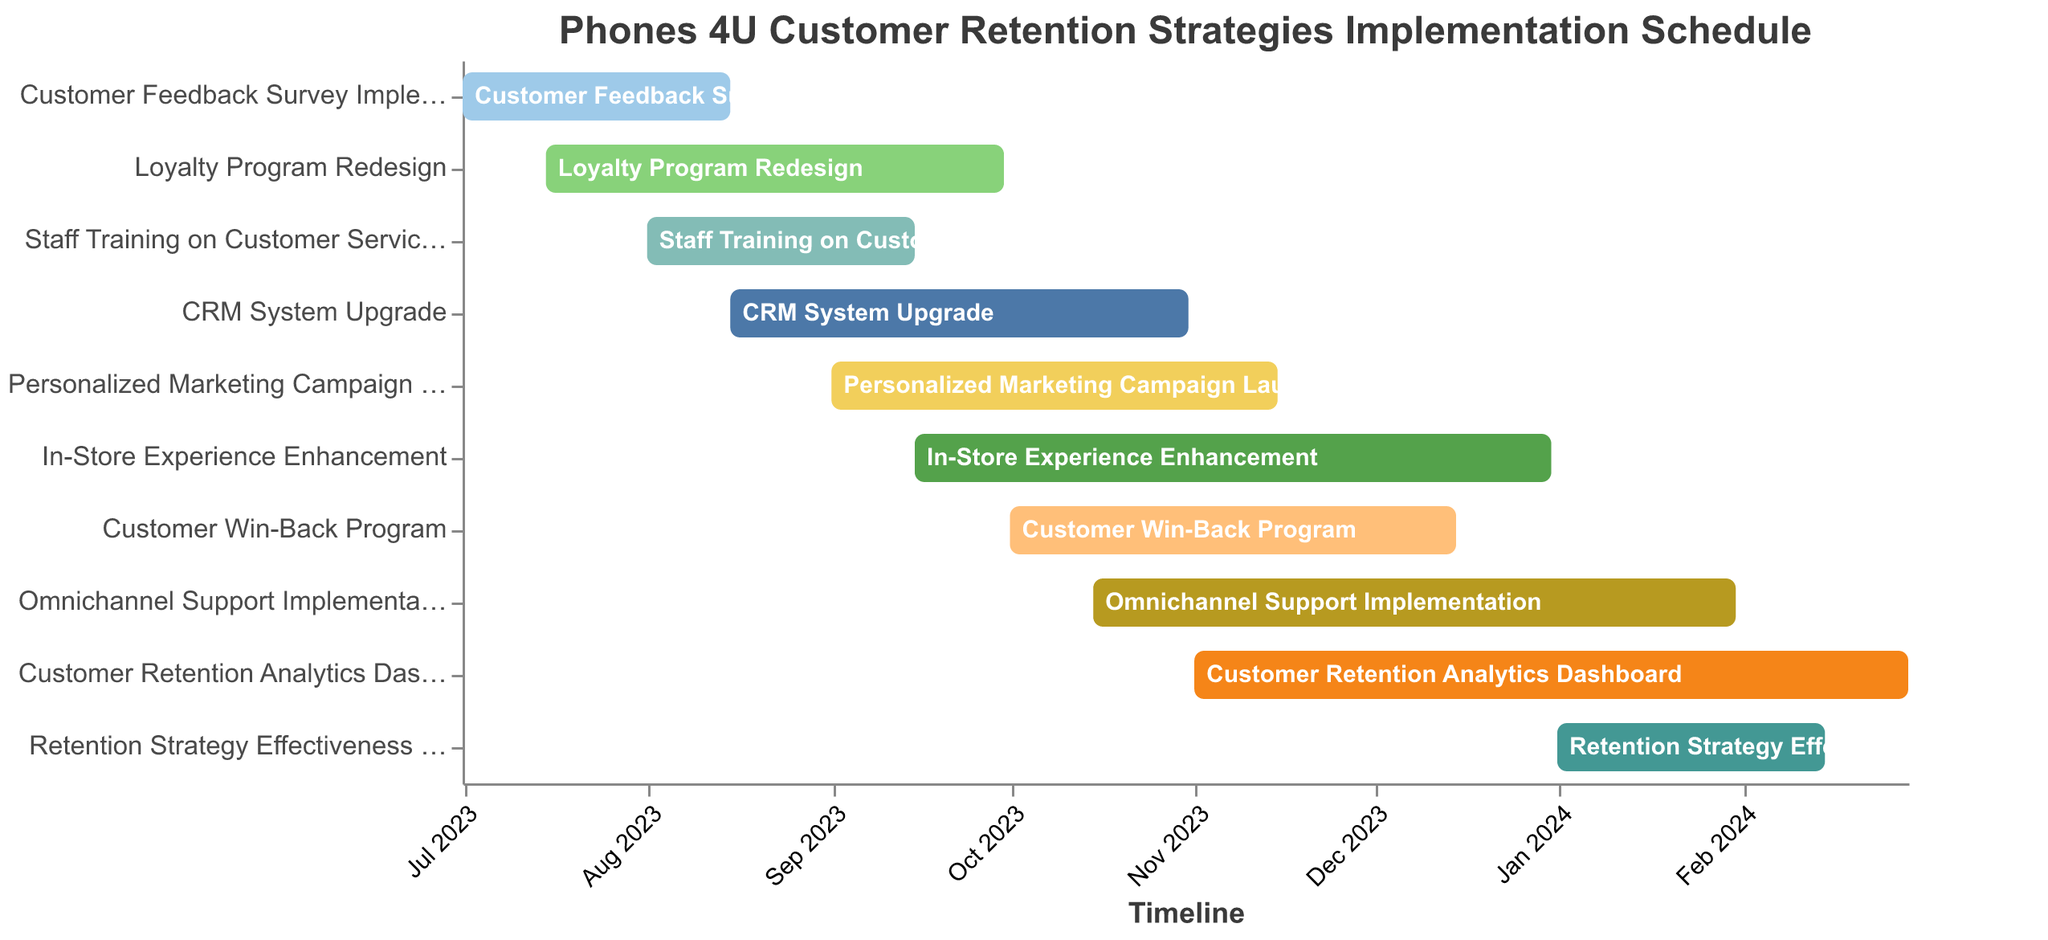What is the title of the chart? The title is often located at the top section of a chart. The chart title provides a summary or subject of the chart.
Answer: Phones 4U Customer Retention Strategies Implementation Schedule How many tasks are displayed in the Gantt chart? Count the number of unique tasks listed on the y-axis of the chart. Each task represents a row in the Gantt chart.
Answer: 10 Which task has the earliest start date? Look at the x-axis to find the earliest (leftmost) start date and then identify which task corresponds to it.
Answer: Customer Feedback Survey Implementation What is the duration of the "Loyalty Program Redesign"? Calculate the difference between the "Start Date" (2023-07-15) and "End Date" (2023-09-30).
Answer: 77 days Which task takes the longest to complete? Compare the lengths of the bars representing each task. The longest bar indicates the task with the longest duration.
Answer: In-Store Experience Enhancement Are there any tasks that overlap completely with each other? If so, which ones? Examine the chart for tasks (bars) that have the same start and end dates or one task's timeline is entirely within another's timeline.
Answer: No tasks overlap completely How many tasks are scheduled to start in September 2023? Identify tasks with a start date within September 2023.
Answer: 3 (Personalized Marketing Campaign Launch, In-Store Experience Enhancement, CRM System Upgrade) Which task ends last on the timeline? Look at the rightmost endpoint on the x-axis to determine which task ends last.
Answer: Customer Retention Analytics Dashboard What is the average duration of all the tasks? Sum the durations of all tasks and divide by the number of tasks. Individual durations need to be calculated first, then averaged.
Answer: 96.2 days How do "Customer Feedback Survey Implementation" and "Loyalty Program Redesign" timelines compare? Compare the start and end dates of each task to evaluate their timelines.
Answer: "Customer Feedback Survey Implementation" starts earlier and ends earlier than "Loyalty Program Redesign" 